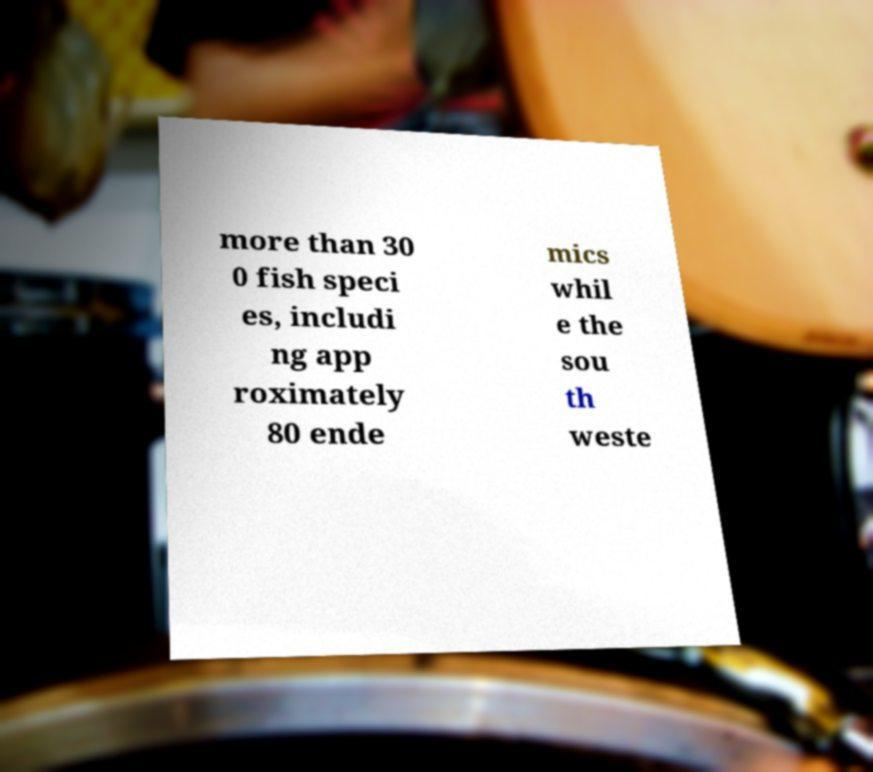Could you assist in decoding the text presented in this image and type it out clearly? more than 30 0 fish speci es, includi ng app roximately 80 ende mics whil e the sou th weste 